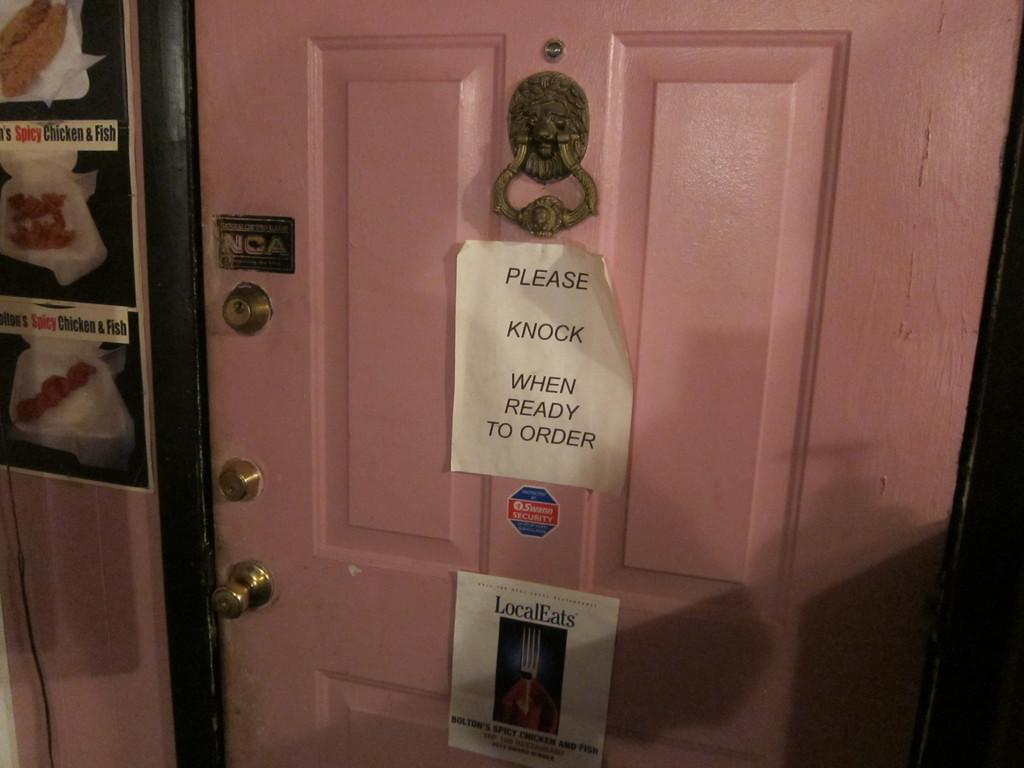<image>
Provide a brief description of the given image. A door has a please knock when ready to order sign on it. 